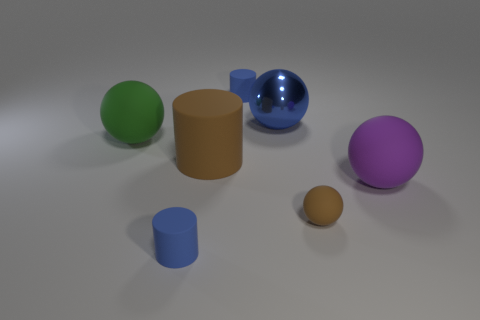There is a blue object that is both on the left side of the large metal object and behind the large purple matte sphere; what shape is it?
Give a very brief answer. Cylinder. Is the large blue object made of the same material as the large brown thing?
Your answer should be compact. No. There is a metallic ball that is the same size as the brown matte cylinder; what color is it?
Keep it short and to the point. Blue. The matte cylinder that is both in front of the big green matte sphere and behind the big purple ball is what color?
Ensure brevity in your answer.  Brown. There is a object that is the same color as the tiny matte sphere; what size is it?
Your answer should be compact. Large. What shape is the big thing that is the same color as the small rubber ball?
Offer a terse response. Cylinder. How big is the metal object that is in front of the tiny object behind the big thing that is behind the green ball?
Make the answer very short. Large. What is the purple object made of?
Offer a very short reply. Rubber. Is the material of the green ball the same as the blue object in front of the green rubber ball?
Offer a very short reply. Yes. Are there any other things of the same color as the shiny object?
Make the answer very short. Yes. 